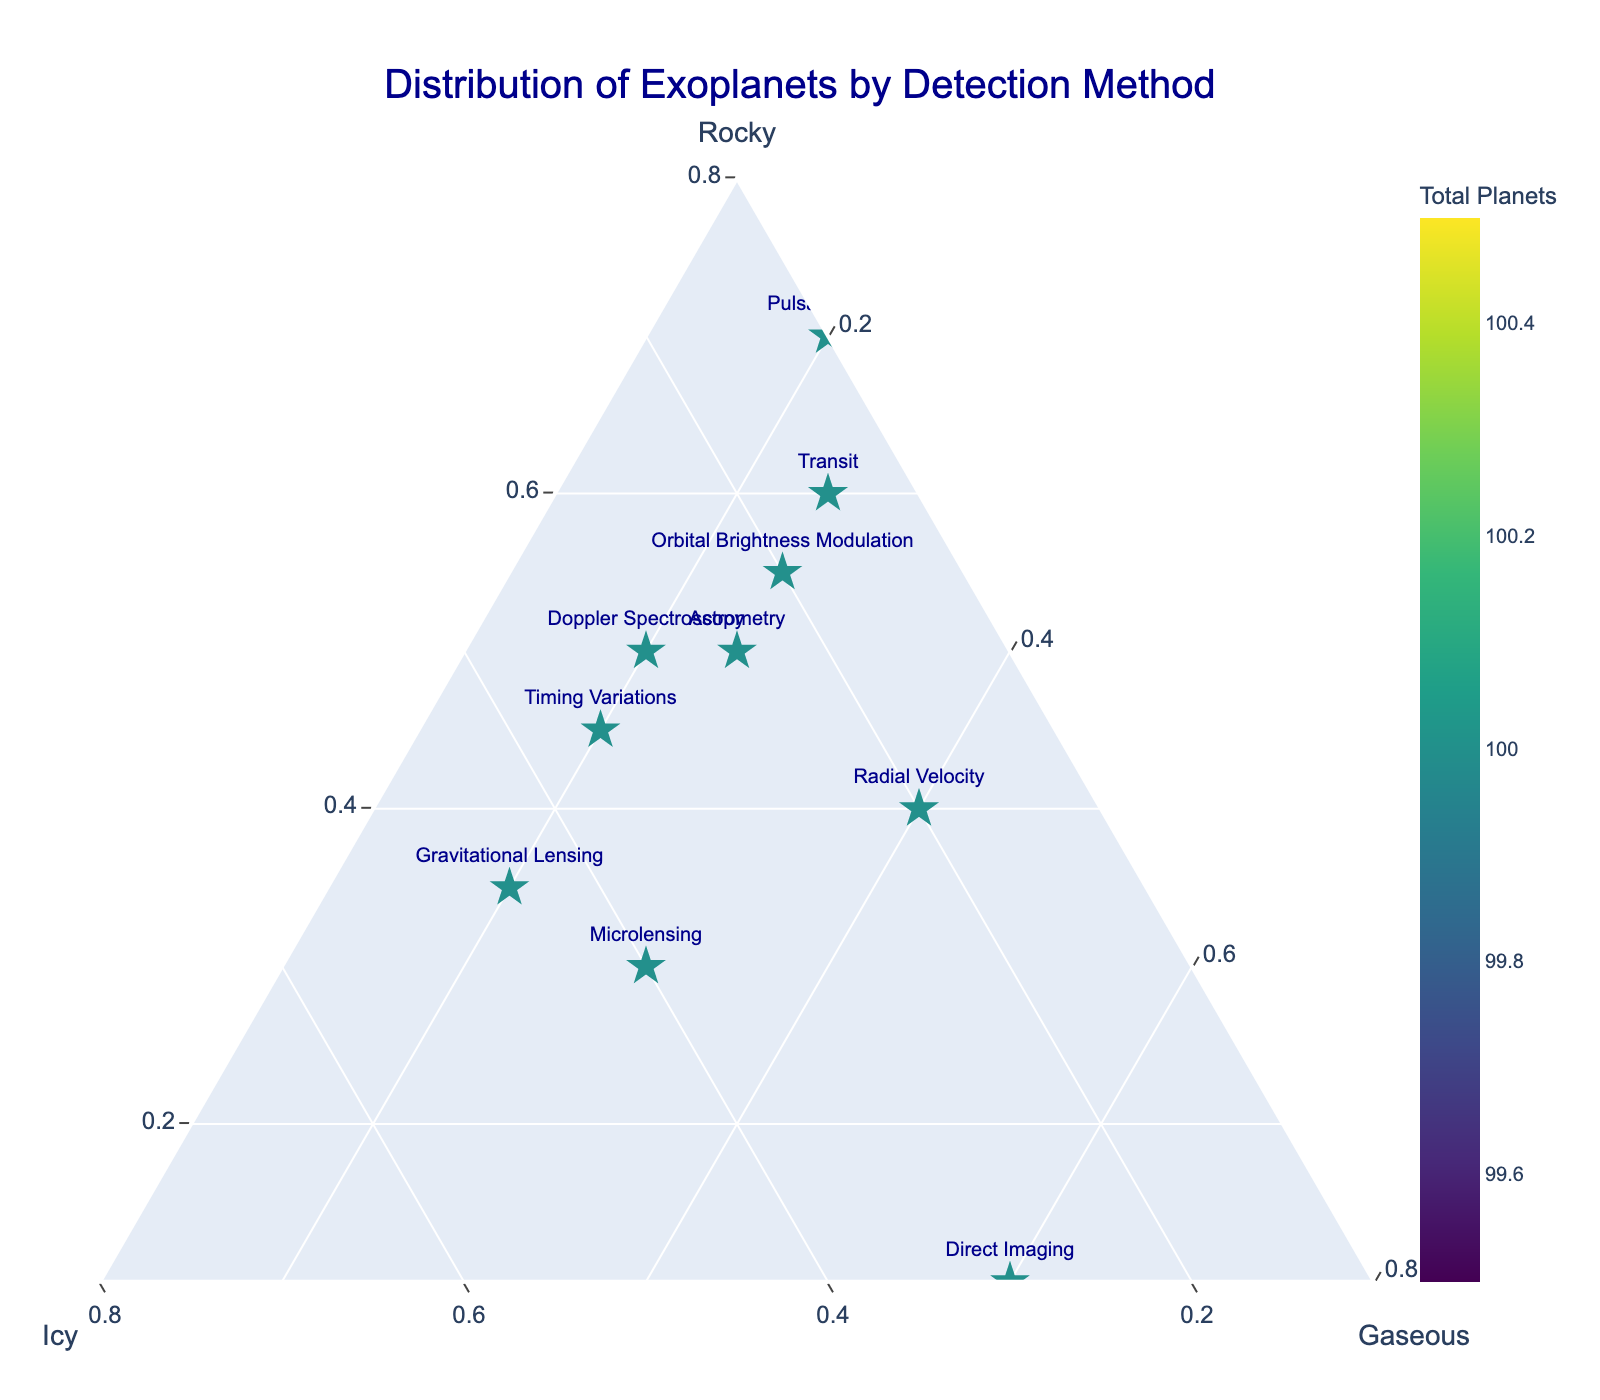What does the title "Distribution of Exoplanets by Detection Method" suggest about the figure? The title tells us that the figure is displaying how different types of exoplanets (rocky, icy, gaseous) are distributed across various methods used to detect them. This guides us to look for differences and similarities in the detection methods as represented by the data points in the ternary plot.
Answer: It presents the distribution of rocky, icy, and gaseous exoplanets detected by different methods How many different detection methods are shown in the plot? By counting the distinct markers labeled with the detection method names on the ternary plot, we can see that there are ten different detection methods represented.
Answer: Ten Which detection method discovered the highest proportion of rocky exoplanets? By observing the markers closer to the 'Rocky' axis, the point labeled "Pulsar Timing" is closest to the 'Rocky' vertex, indicating a high proportion of rocky exoplanets.
Answer: Pulsar Timing What is the color of the point representing the method that discovered a balanced distribution of rocky, icy, and gaseous exoplanets? The balanced distribution is at the center of the ternary plot. The point labeled "Microlensing" is near the center with a greenish color, implying a balanced discovery.
Answer: Greenish Which method discovered the most gaseous exoplanets relative to other types? By looking at the markers closest to the 'Gaseous' vertex, the "Direct Imaging" method is the closest, indicating that it discovered the most gaseous exoplanets relative to rocky and icy ones.
Answer: Direct Imaging Which detection method discovered the fewest total exoplanets? By examining the color scale (where darker colors represent fewer total exoplanets), the "Direct Imaging" method has a darker marker, showing it discovered the fewest exoplanets.
Answer: Direct Imaging Is there a detection method that discovered an equal number of rocky and icy exoplanets? If so, which one? Locate markers along the line equidistant from the 'Rocky' and 'Icy' axes. The "Astrometry" and "Timing Variations" methods have markers that align closely with this line. However, further checking reveals only "Astrometry" has exactly equal numbers.
Answer: Astrometry Which detection method discovered 50 rocky exoplanets? Look for the markers labeled with the various detection methods and find the one whose position aligns with 50% rocky. "Astrometry" and "Doppler Spectroscopy" markers show this value.
Answer: Astrometry and Doppler Spectroscopy Which method is represented by a marker closest to the 'Icy' vertex? The marker closest to the 'Icy' vertex represents the detection method that discovered the highest proportion of icy exoplanets. This marker is labeled "Gravitational Lensing."
Answer: Gravitational Lensing What proportion of the exoplanets discovered by the "Transit" method are icy? To determine this, look at the position of the "Transit" marker in relation to the 'Icy' axis. The location appears to show it is about 15% icy.
Answer: 15% 